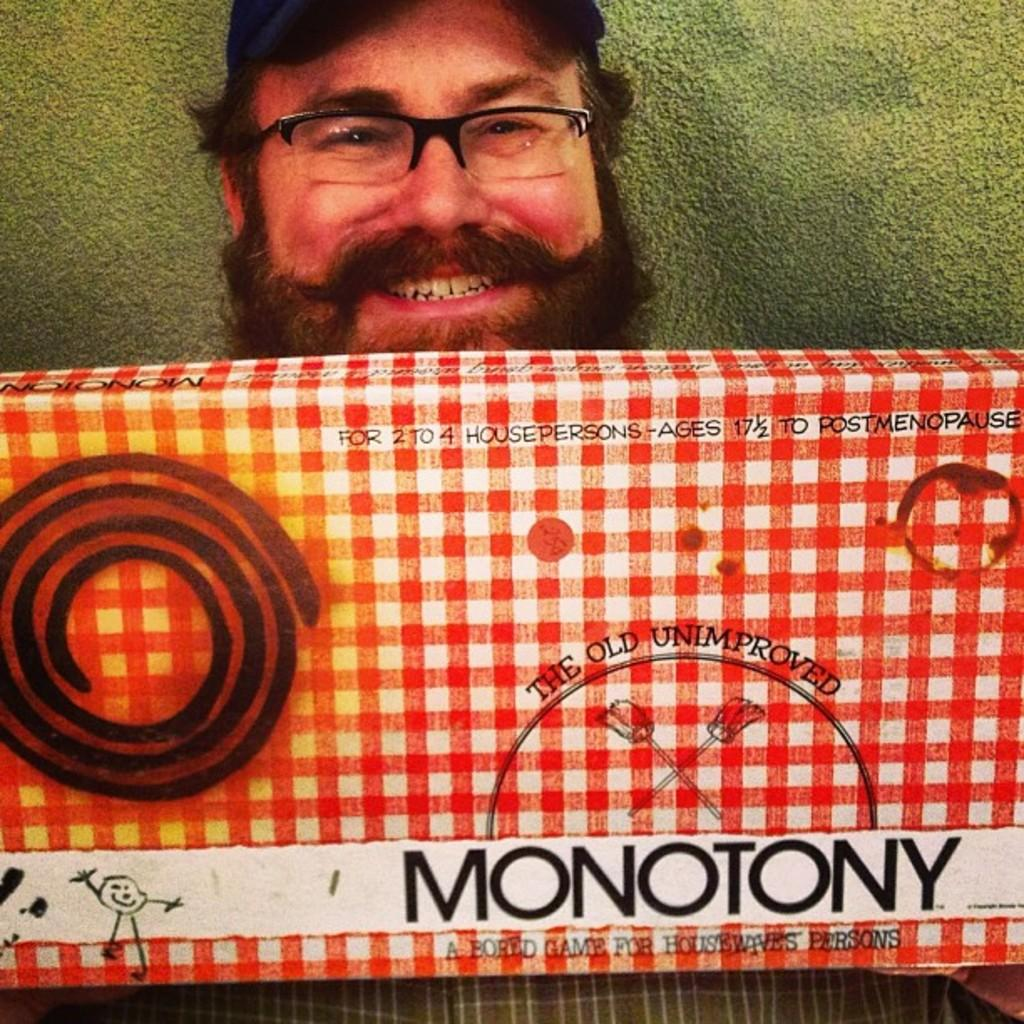What is present in the image? There is a man in the image. What is the man holding? The man is holding an object that resembles a box. Can you describe the box? The box has writing on it. What can be seen in the background of the image? There is a wall in the background of the image. What time is indicated on the hourglass in the image? There is no hourglass present in the image; it features a man holding a box with writing on it. Is there a fire visible in the image? No, there is no fire visible in the image. 